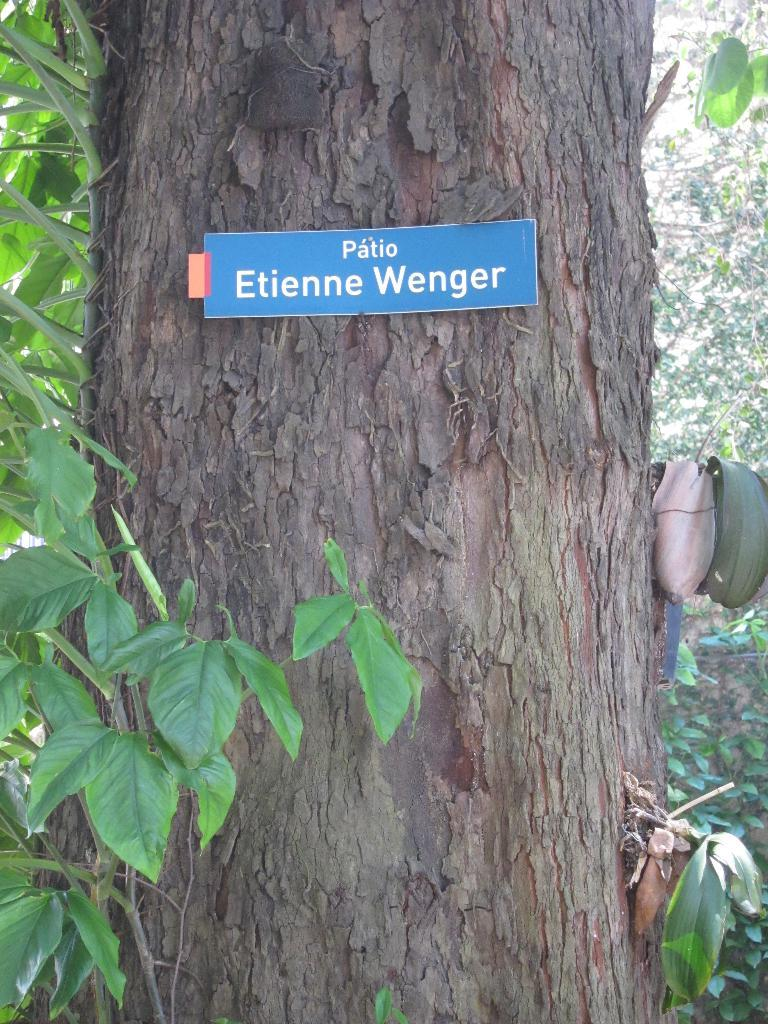What is the main subject in the middle of the image? There is a tree stem in the middle of the image. What is attached to the tree stem? A blue color board with text is pasted on the tree stem. What can be seen in the background of the image? There are trees visible in the background of the image. How does the tree care for the rest of the forest in the image? The image does not show the tree caring for the rest of the forest, nor does it depict any actions or interactions between the tree and other trees. 